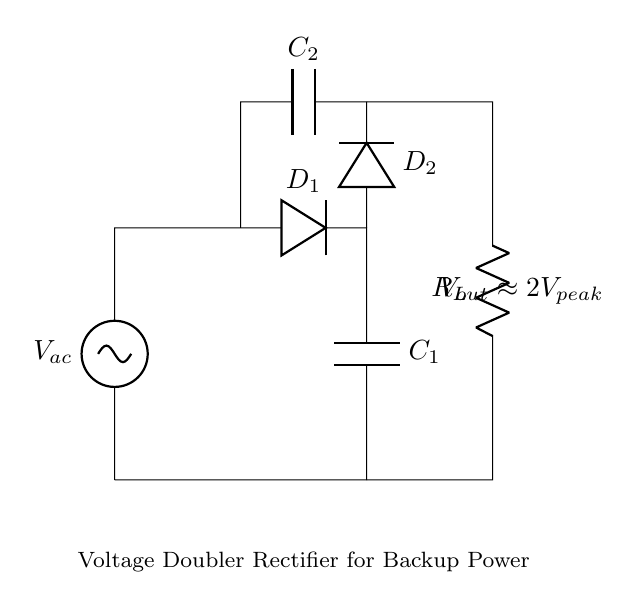What type of circuit is shown? The circuit is a voltage doubler rectifier, characterized by its use of diodes and capacitors to double the output voltage from an AC source.
Answer: Voltage doubler rectifier What is the value of the output voltage? The output voltage is approximately double the peak voltage of the input AC voltage. Given the notation, it's defined as two times the peak voltage (V_peak).
Answer: 2V_peak What is the purpose of capacitor C1? Capacitor C1 smooths the output voltage by providing charge storage, allowing for a more stable DC output by reducing ripple.
Answer: Smoothing How many diodes are used in the circuit? There are two diodes used in the circuit to facilitate the rectification process in both halves of the AC cycle.
Answer: 2 Why is there a load resistance R_L? The load resistance R_L is incorporated to represent the load that the rectifier is supplying power to, which affects both the output voltage and current drawn from the circuit.
Answer: To represent load What role does capacitor C2 play in this circuit? Capacitor C2 works in conjunction with C1 during the rectification process to further enhance the voltage doubling effect and improve the output voltage stability.
Answer: Voltage doubling What is the significance of the term "peak" in V_peak? V_peak refers to the maximum voltage value reached by the AC waveform, which is critical for calculating the output voltage of the doubler rectifier since the output is derived from this peak value.
Answer: Maximum voltage 